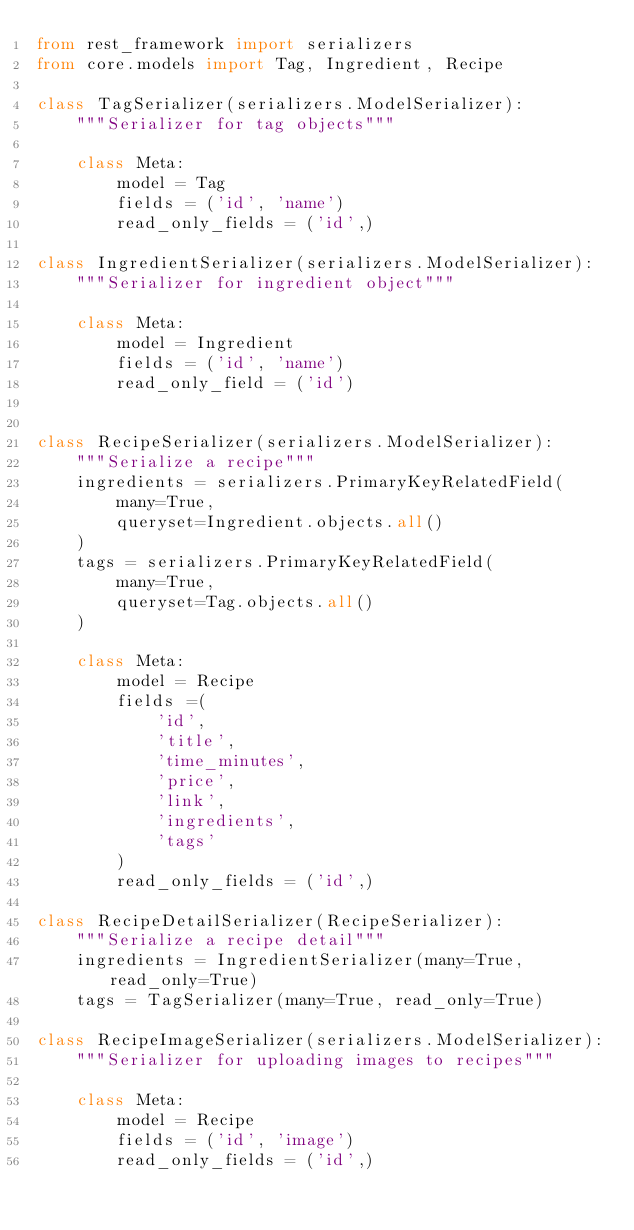<code> <loc_0><loc_0><loc_500><loc_500><_Python_>from rest_framework import serializers
from core.models import Tag, Ingredient, Recipe

class TagSerializer(serializers.ModelSerializer):
    """Serializer for tag objects"""

    class Meta:
        model = Tag
        fields = ('id', 'name')
        read_only_fields = ('id',)

class IngredientSerializer(serializers.ModelSerializer):
    """Serializer for ingredient object"""
    
    class Meta:
        model = Ingredient
        fields = ('id', 'name')
        read_only_field = ('id')


class RecipeSerializer(serializers.ModelSerializer):
    """Serialize a recipe"""
    ingredients = serializers.PrimaryKeyRelatedField(
        many=True,
        queryset=Ingredient.objects.all()
    )
    tags = serializers.PrimaryKeyRelatedField(
        many=True,
        queryset=Tag.objects.all()
    )

    class Meta:
        model = Recipe
        fields =(
            'id', 
            'title', 
            'time_minutes', 
            'price', 
            'link', 
            'ingredients', 
            'tags'
        )
        read_only_fields = ('id',)

class RecipeDetailSerializer(RecipeSerializer):
    """Serialize a recipe detail"""
    ingredients = IngredientSerializer(many=True, read_only=True)
    tags = TagSerializer(many=True, read_only=True)

class RecipeImageSerializer(serializers.ModelSerializer):
    """Serializer for uploading images to recipes"""

    class Meta:
        model = Recipe
        fields = ('id', 'image')
        read_only_fields = ('id',)

</code> 